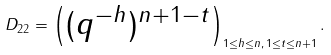Convert formula to latex. <formula><loc_0><loc_0><loc_500><loc_500>D _ { 2 2 } = \begin{pmatrix} ( q ^ { - h } ) ^ { n + 1 - t } \end{pmatrix} _ { 1 \leq h \leq n , \, 1 \leq t \leq n + 1 } .</formula> 